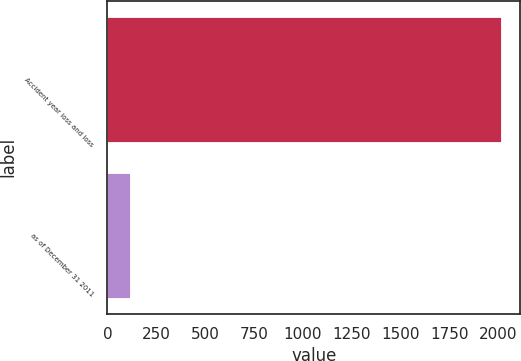Convert chart. <chart><loc_0><loc_0><loc_500><loc_500><bar_chart><fcel>Accident year loss and loss<fcel>as of December 31 2011<nl><fcel>2010<fcel>114<nl></chart> 